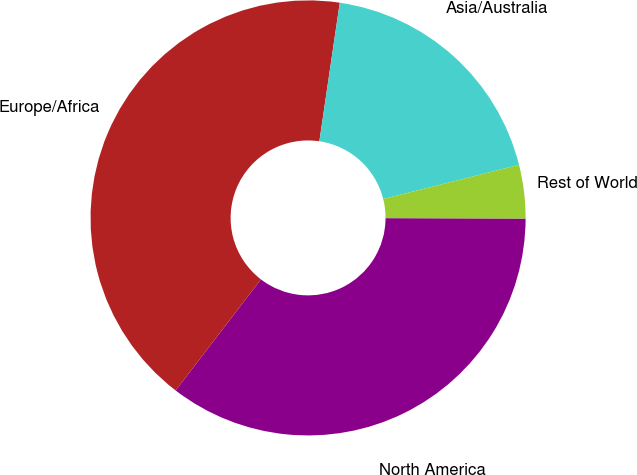Convert chart to OTSL. <chart><loc_0><loc_0><loc_500><loc_500><pie_chart><fcel>North America<fcel>Europe/Africa<fcel>Asia/Australia<fcel>Rest of World<nl><fcel>35.37%<fcel>41.91%<fcel>18.75%<fcel>3.97%<nl></chart> 